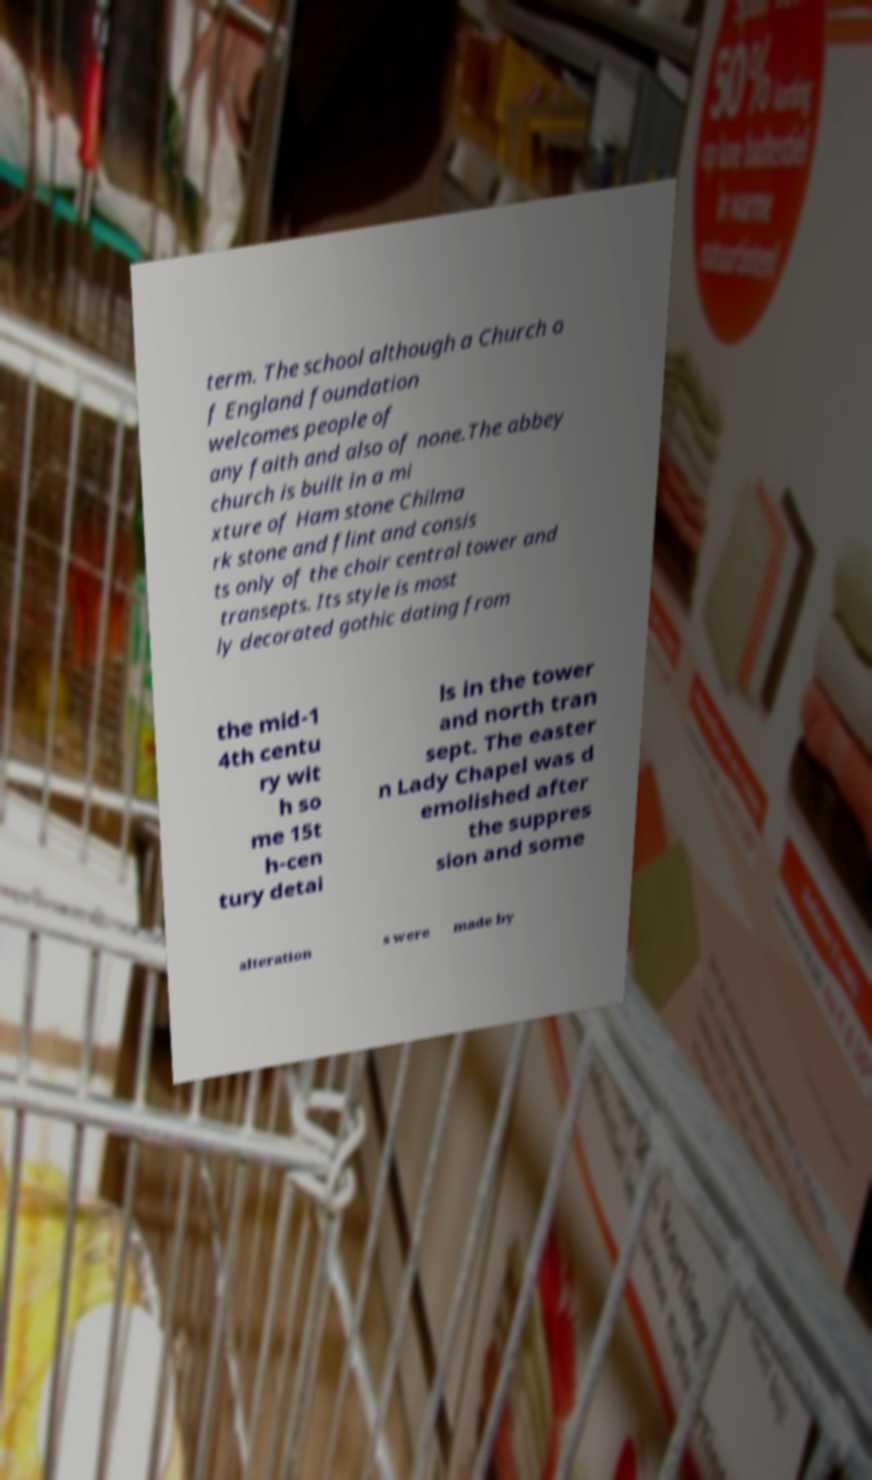Could you assist in decoding the text presented in this image and type it out clearly? term. The school although a Church o f England foundation welcomes people of any faith and also of none.The abbey church is built in a mi xture of Ham stone Chilma rk stone and flint and consis ts only of the choir central tower and transepts. Its style is most ly decorated gothic dating from the mid-1 4th centu ry wit h so me 15t h-cen tury detai ls in the tower and north tran sept. The easter n Lady Chapel was d emolished after the suppres sion and some alteration s were made by 